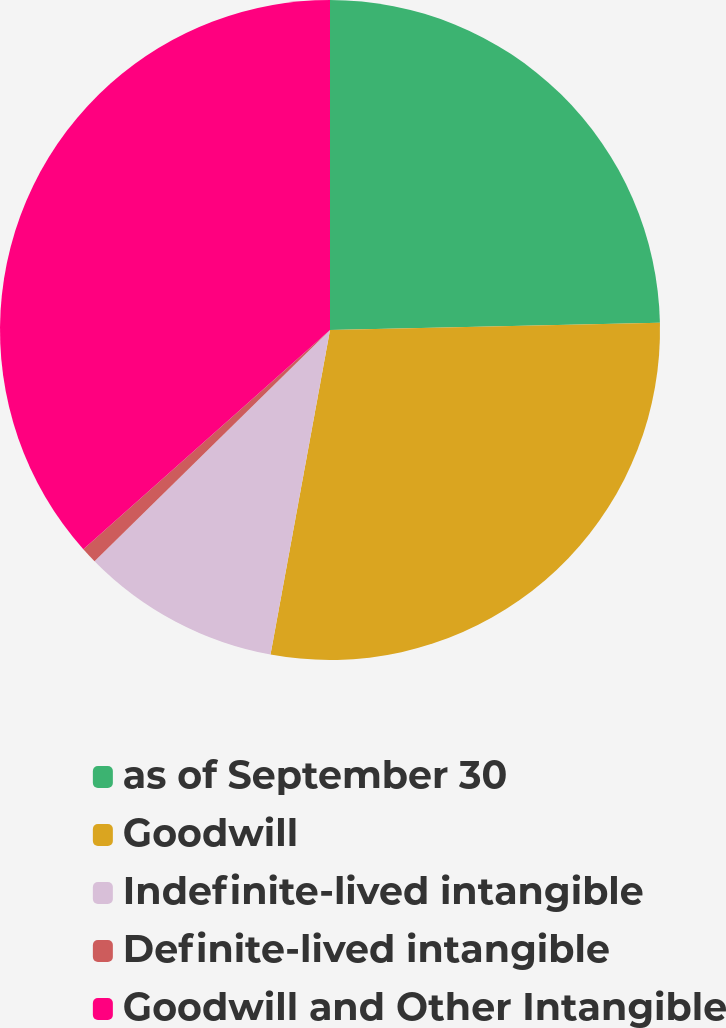Convert chart to OTSL. <chart><loc_0><loc_0><loc_500><loc_500><pie_chart><fcel>as of September 30<fcel>Goodwill<fcel>Indefinite-lived intangible<fcel>Definite-lived intangible<fcel>Goodwill and Other Intangible<nl><fcel>24.65%<fcel>28.23%<fcel>9.76%<fcel>0.79%<fcel>36.56%<nl></chart> 